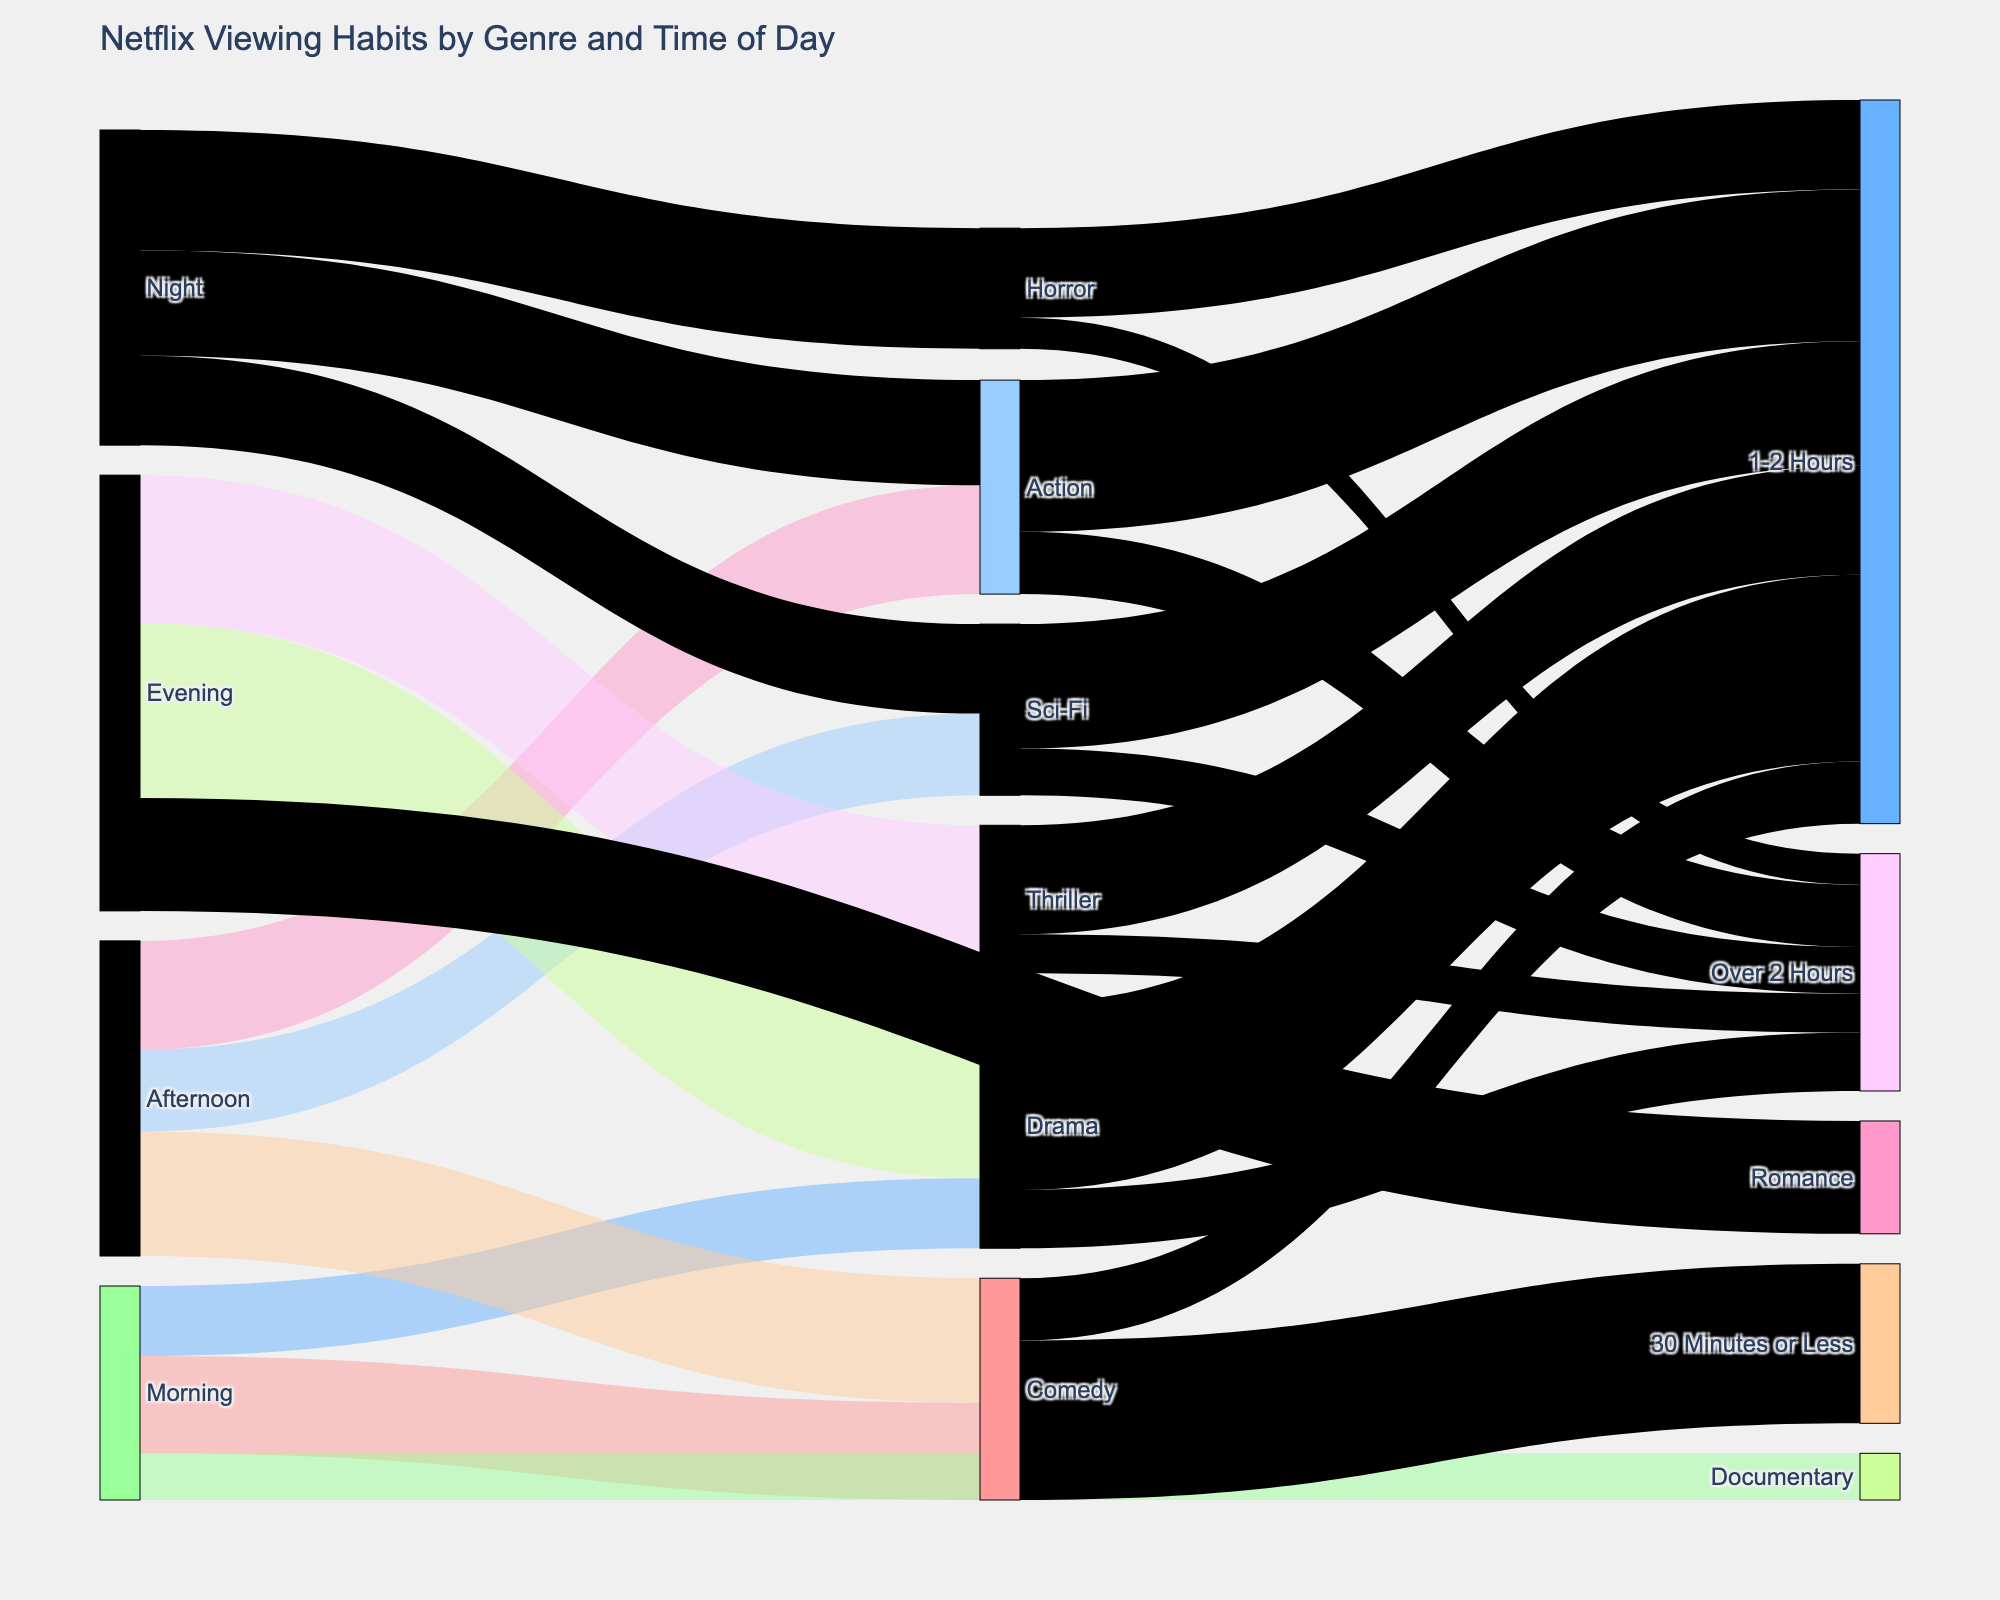How many genres are shown in the diagram? To find the number of genres, look at labels in the middle column of the Sankey diagram. These labels represent different genres. Count the number of distinct genres appearing.
Answer: 8 What is the most popular genre watched in the morning? Look at the links originating from "Morning" and check the values associated with each genre. The highest value will indicate which genre is most popular in the morning.
Answer: Comedy Which time of day has the highest viewership for the Drama genre? Find all the links connected to "Drama" and look at their source nodes (Morning, Afternoon, Evening, or Night). The time of day with the highest value linked to "Drama" is the answer.
Answer: Evening How many total viewings are recorded for Sci-Fi across all times of day? Add up the values of all the links that target the "Sci-Fi" genre from various times of day (Afternoon and Night).
Answer: 440 For the Comedy genre, which viewing length is more popular, 30 Minutes or Less, or 1-2 Hours? Look at the links that target "Comedy" and check their values. Compare the value linked to "30 Minutes or Less" with the one linked to "1-2 Hours".
Answer: 30 Minutes or Less How many more viewings does Horror get at night compared to the morning? Find the value of the link between "Night" and "Horror" and the value of the link between "Morning" and "Horror" (which is absent indicating a value of zero in the morning). Subtract the morning viewings from the night viewings.
Answer: 310 Which genre has the smallest viewer count in the Afternoon? Look at the links originating from "Afternoon" and identify the smallest value linked to a genre.
Answer: Sci-Fi Is the length "Over 2 Hours" more popular for Action or for Horror? Compare the link values for "Action" to "Over 2 Hours" and "Horror" to "Over 2 Hours". Check which value is larger.
Answer: Action Which genre has the largest span in viewing length from 30 Minutes or Less to Over 2 Hours? Compare the links for each genre that map to "30 Minutes or Less", "1-2 Hours", and "Over 2 Hours". Find the genre with the most diverse distribution across these lengths.
Answer: Comedy What is the total viewership count for all genres at night? Sum the values of the links that originate from "Night" and leads to various genres.
Answer: 810 